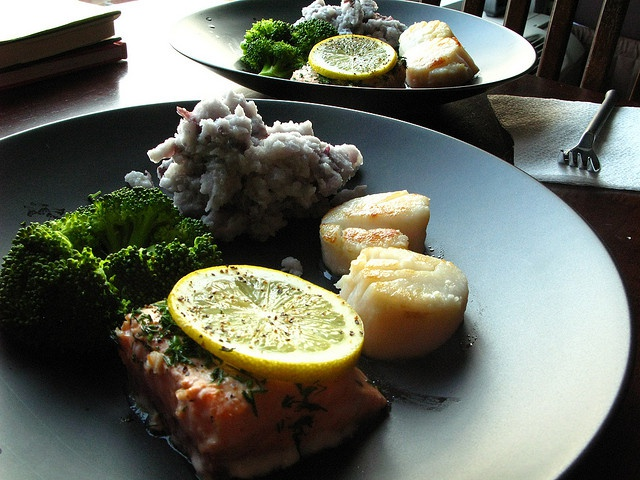Describe the objects in this image and their specific colors. I can see bowl in white, lightgray, black, gray, and lightblue tones, bowl in white, black, ivory, gray, and darkgray tones, broccoli in white, black, darkgreen, and olive tones, chair in white, black, gray, and darkgray tones, and broccoli in white, black, darkgreen, and olive tones in this image. 